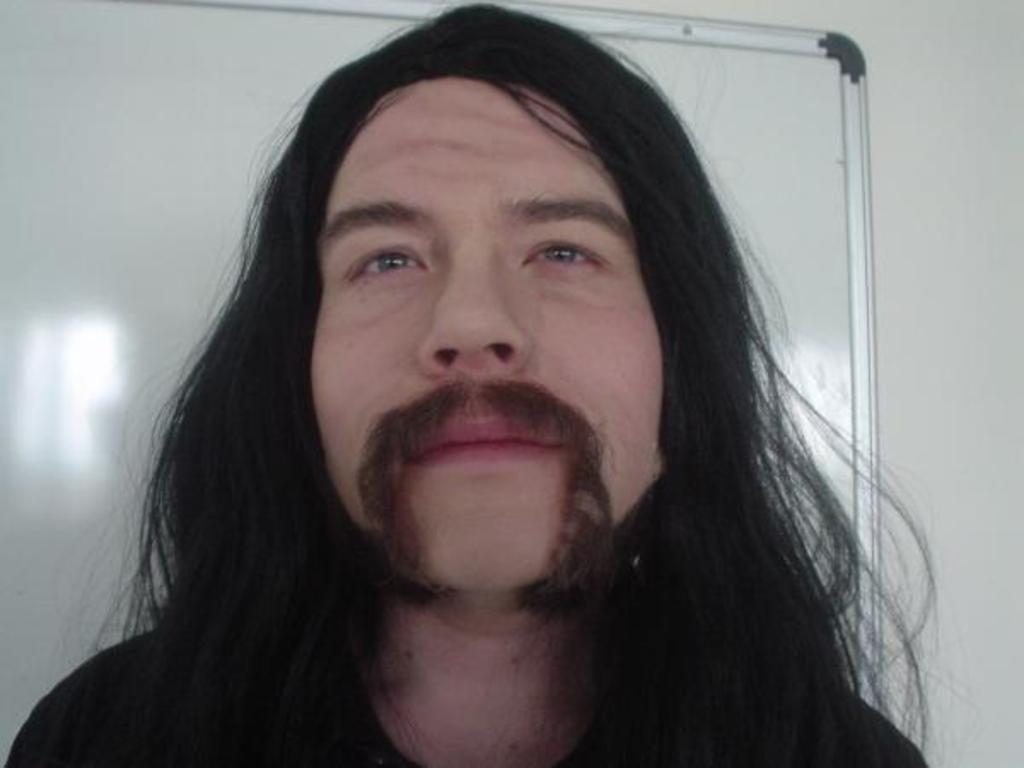What is the appearance of the man in the image? There is a man with long hair in the image. What can be seen on the wall in the background of the image? There is a whiteboard on the wall in the background of the image. What type of rifle is the man holding in the image? There is no rifle present in the image; the man is not holding any object. 